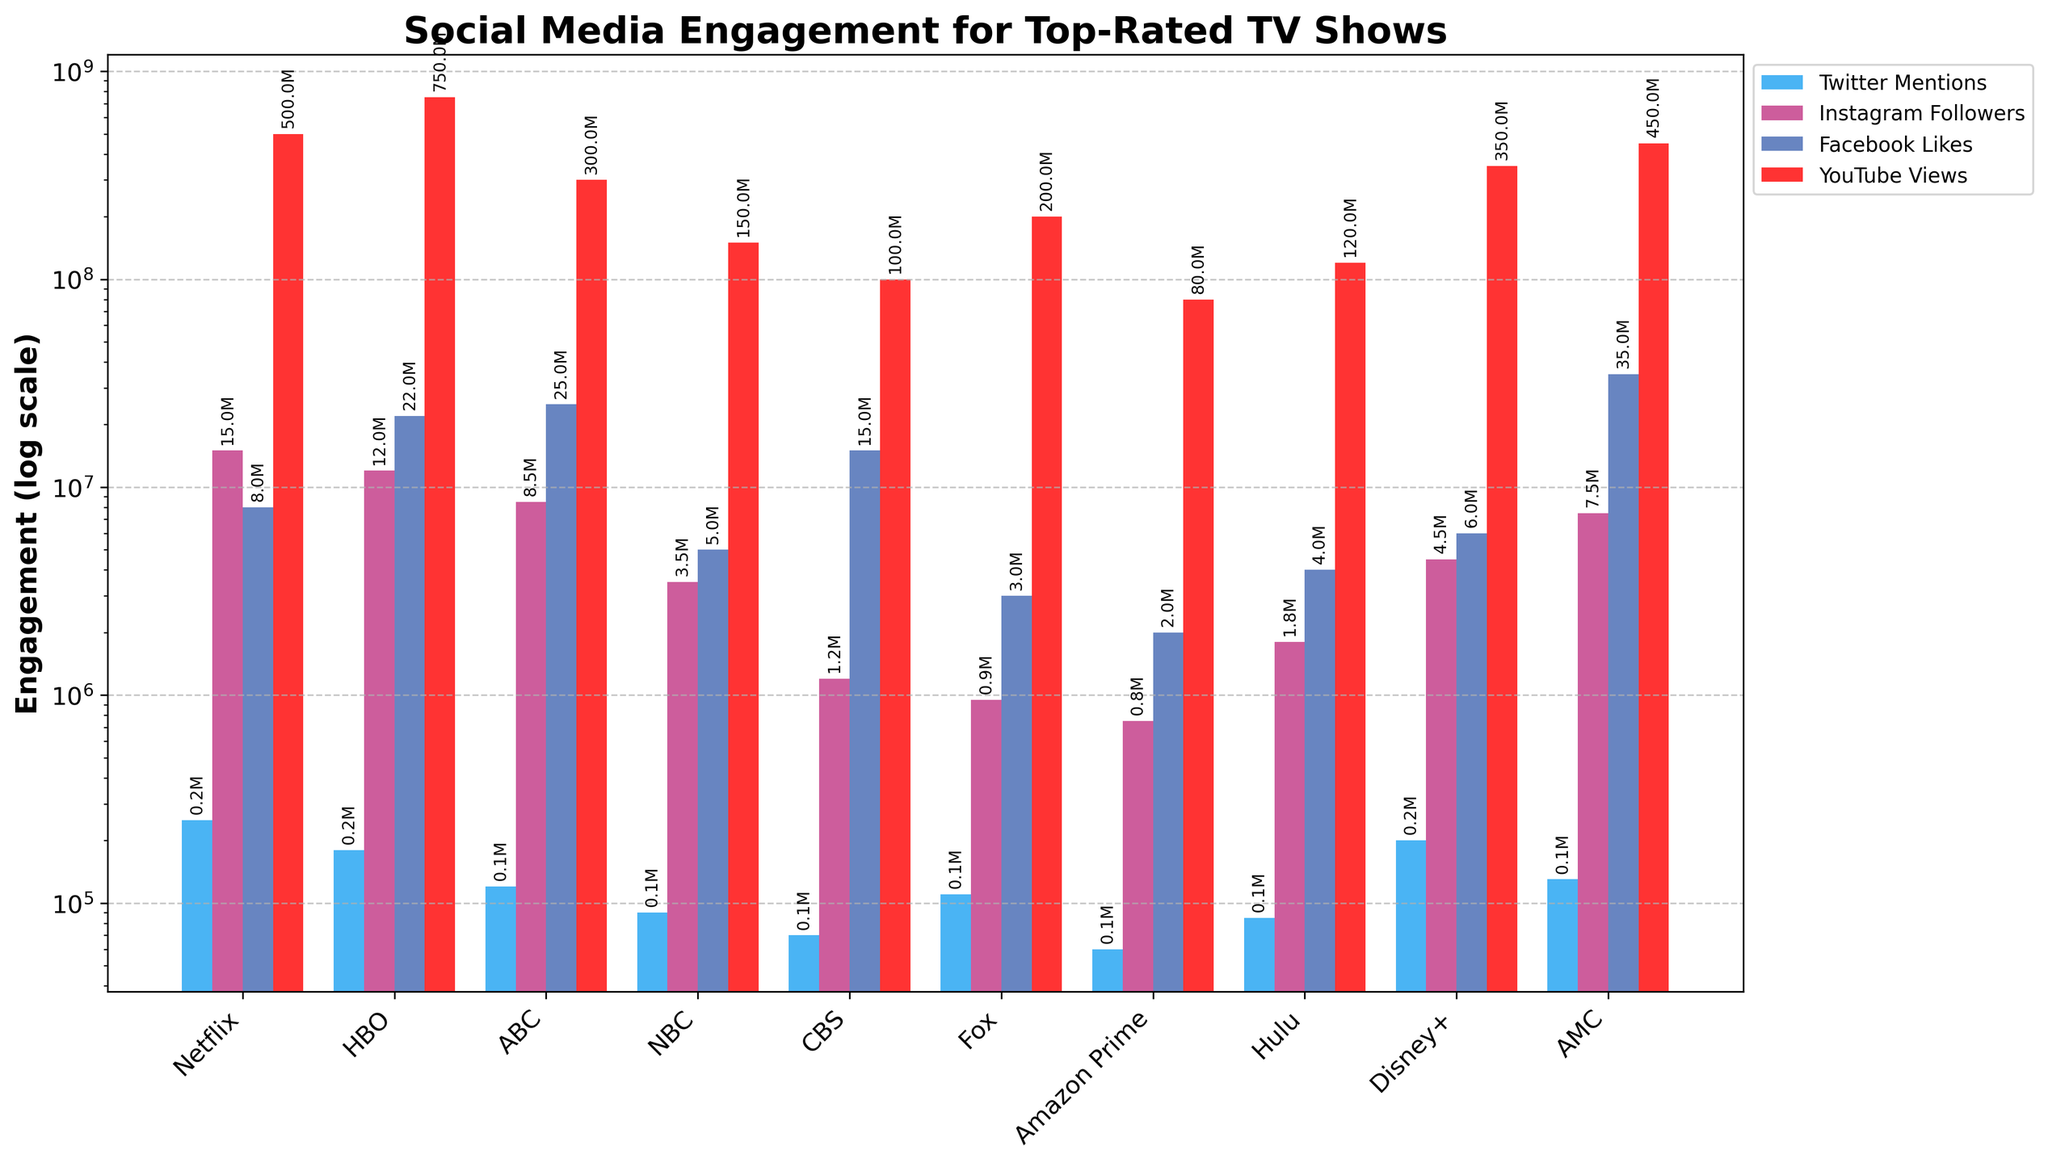Which show has the highest number of Facebook Likes? Compare the heights of the Facebook Likes bars for all the shows. The highest bar corresponds to The Walking Dead.
Answer: The Walking Dead Which platform's show has the highest YouTube Views? Look at the heights of the YouTube Views bars. The tallest bar is for Game of Thrones on HBO.
Answer: HBO What is the sum of Instagram Followers for Stranger Things and Game of Thrones? Add the Instagram Followers values for both shows: Stranger Things (15,000,000) + Game of Thrones (12,000,000). The sum is 27,000,000.
Answer: 27,000,000 Which show has the fewest Twitter Mentions and how many are there? Identify the shortest bar for Twitter Mentions. The Marvelous Mrs. Maisel has the fewest Twitter Mentions at 60,000.
Answer: The Marvelous Mrs. Maisel, 60,000 What is the average number of Instagram Followers for shows on Disney+ and NBC? Add the Instagram Followers for Disney+ (4,500,000) and NBC (3,500,000), then divide by 2. The sum is 8,000,000 and the average is 4,000,000.
Answer: 4,000,000 Which show has more Facebook Likes, Grey's Anatomy or NCIS? Compare the heights of the Facebook Likes bars for the two shows. Grey's Anatomy has more Likes (25,000,000) than NCIS (15,000,000).
Answer: Grey's Anatomy What is the difference in YouTube Views between This Is Us and The Handmaid's Tale? Subtract the YouTube Views of The Handmaid's Tale from This Is Us: 150,000,000 - 120,000,000 = 30,000,000.
Answer: 30,000,000 Which social media platform has the biggest disparity in engagement between Stranger Things and The Marvelous Mrs. Maisel? Compare the differences in engagement for each platform between the two shows. The biggest disparity is on YouTube, where Stranger Things has 500,000,000 and The Marvelous Mrs. Maisel has 80,000,000. The difference is 420,000,000.
Answer: YouTube Among the top-rated TV shows, which has the highest total engagement across all platforms? Sum the engagement metrics for each show and compare the totals. Game of Thrones has the highest total engagement with:
Twitter Mentions = 180,000
Instagram Followers = 12,000,000
Facebook Likes = 22,000,000
YouTube Views = 750,000,000
Total = 784,180,000.
Answer: Game of Thrones 